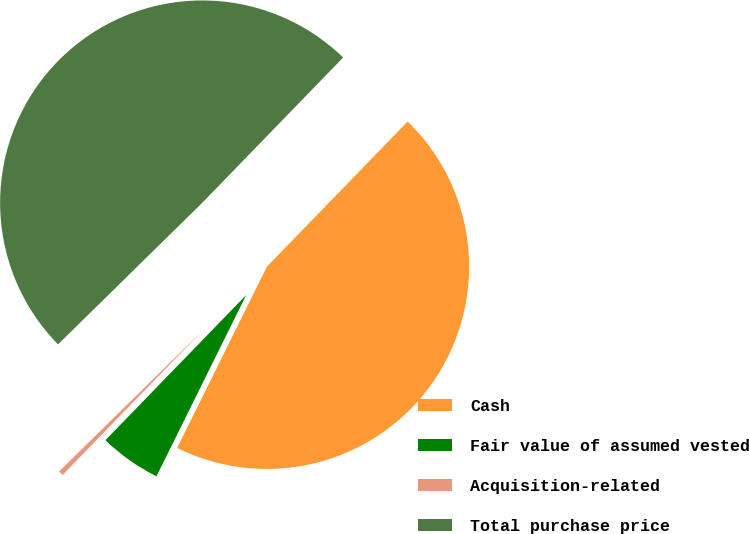<chart> <loc_0><loc_0><loc_500><loc_500><pie_chart><fcel>Cash<fcel>Fair value of assumed vested<fcel>Acquisition-related<fcel>Total purchase price<nl><fcel>45.06%<fcel>4.94%<fcel>0.39%<fcel>49.61%<nl></chart> 